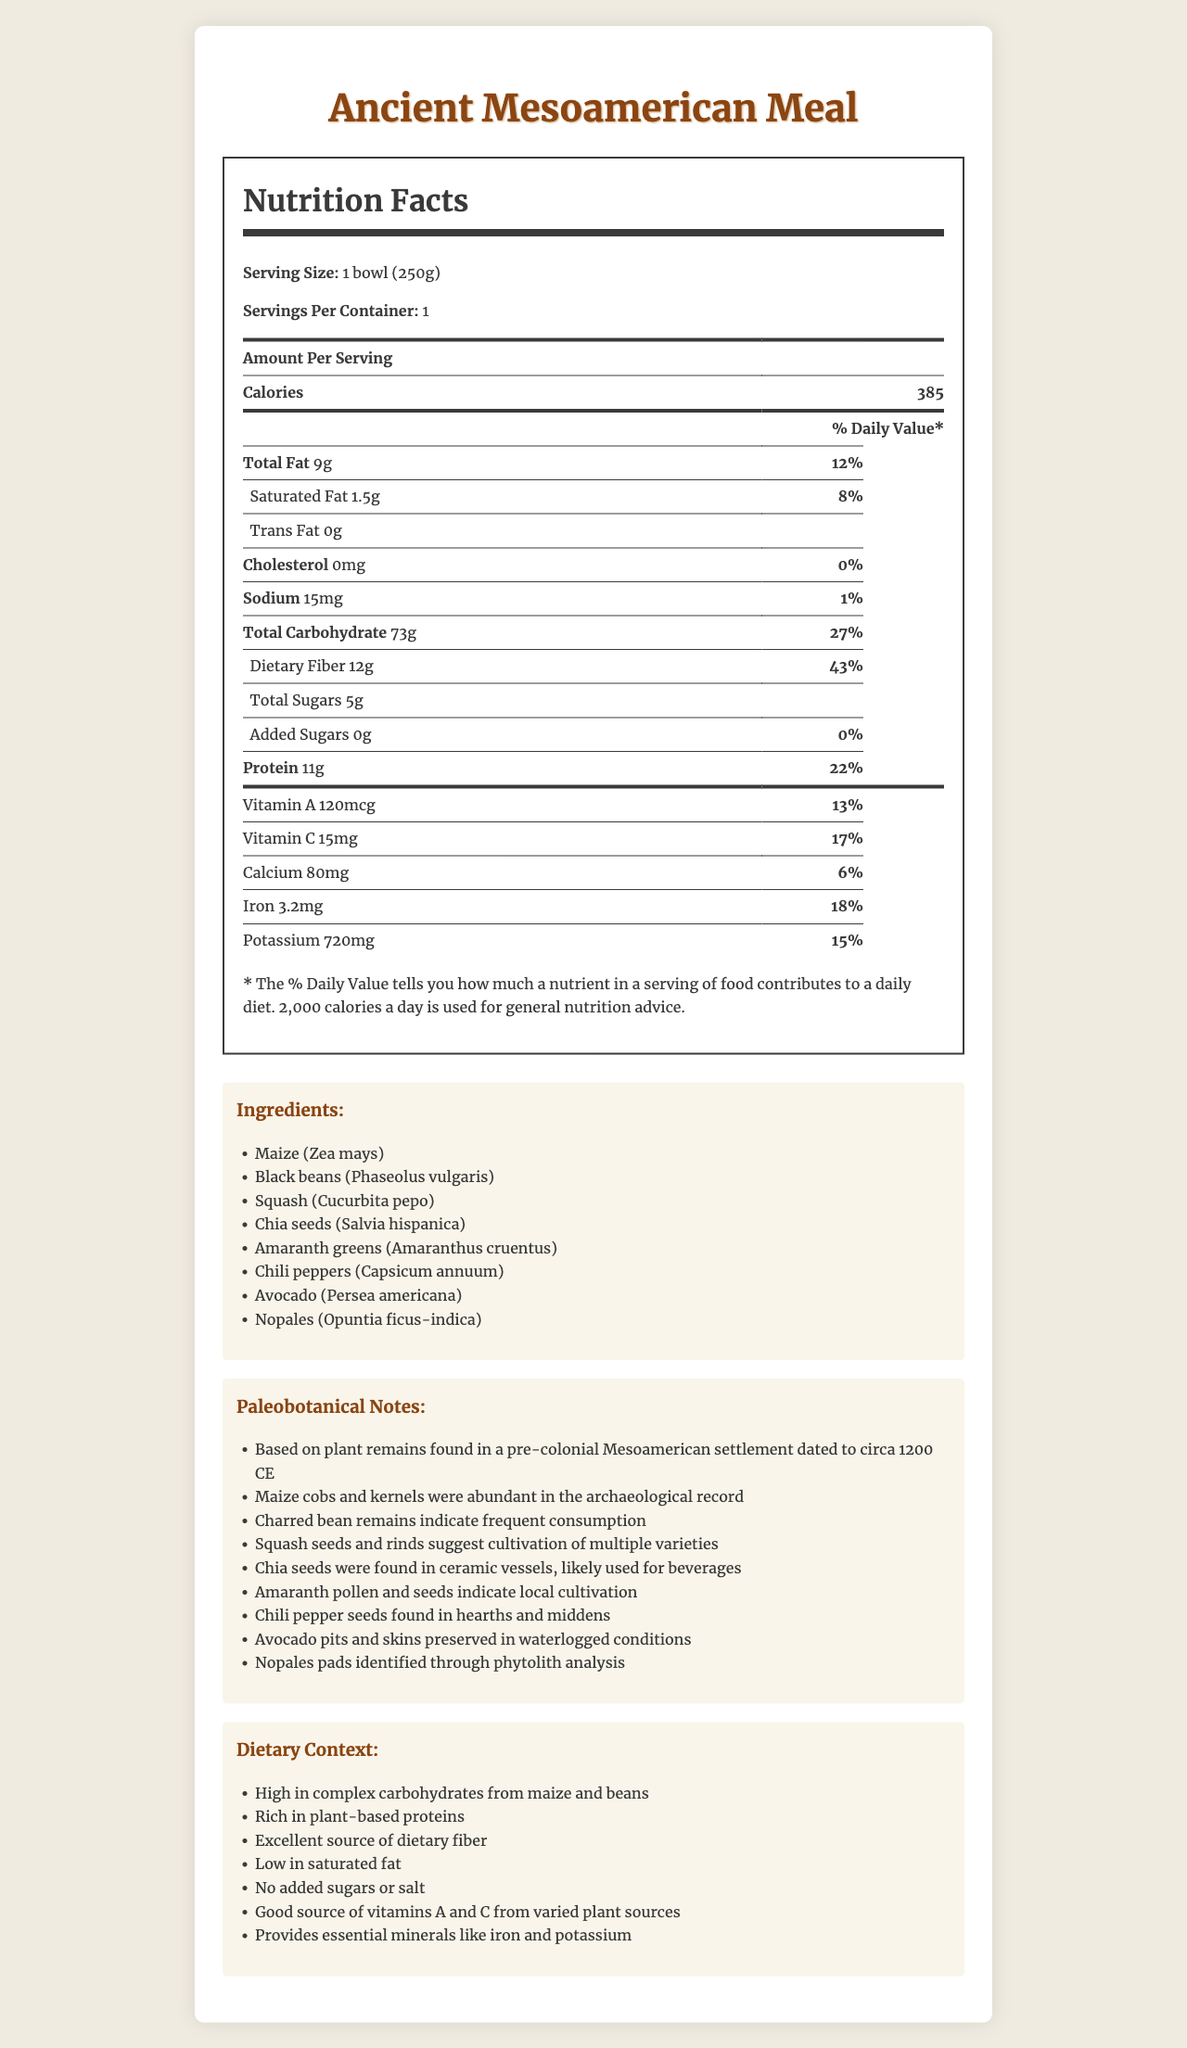what is the serving size of the Ancient Mesoamerican Meal? The serving size is specified at the top of the Nutrition Facts label as "1 bowl (250g)."
Answer: 1 bowl (250g) how many calories are in each serving? The document states that each serving contains 385 calories, highlighted under the "Amount Per Serving" section.
Answer: 385 which ingredient is primarily high in complex carbohydrates? According to the dietary context, maize is highlighted as being high in complex carbohydrates, which is typical for this grain.
Answer: Maize (Zea mays) list three sources of protein found in the Ancient Mesoamerican Meal. According to the ingredients list, black beans, chia seeds, and amaranth greens are all known sources of plant-based protein.
Answer: Black beans, chia seeds, amaranth greens what is the % Daily Value of Dietary Fiber? The % Daily Value for dietary fiber is 43%, as specified next to the dietary fiber content on the Nutrition Facts label.
Answer: 43% which of the following vitamins are provided by the Ancient Mesoamerican Meal?
A. Vitamin A
B. Vitamin C
C. Vitamin D The Nutrition Facts label shows that the meal provides Vitamin A (120mcg) and Vitamin C (15mg), but does not list Vitamin D.
Answer: A and B what is the total carbohydrate content per serving? The Nutrition Facts label lists 73 grams of total carbohydrates per serving, under the "Total Carbohydrate" section.
Answer: 73g does this meal contain any cholesterol? The Nutrition Facts label indicates 0mg of cholesterol, which means there is no cholesterol in the meal.
Answer: No which food item was found charred and suggests frequent consumption? The paleobotanical notes mention charred bean remains indicating frequent consumption, specifically referring to black beans.
Answer: Black beans what are the benefits highlighted in the dietary context of this meal? The dietary context section lists these benefits, providing a broad overview of the nutritional advantages of the meal.
Answer: High in complex carbohydrates, rich in plant-based proteins, excellent source of dietary fiber, low in saturated fat, no added sugars or salt, good source of vitamins A and C, essential minerals like iron and potassium could the amount of trans fat in this meal be determined from the document? The document shows that there is 0 grams of trans fat, indicating no trans fat content in the meal.
Answer: Yes what is the main idea of the document? The document offers a comprehensive overview of the meal's nutritional profile and background, emphasizing its basis on paleobotanical evidence and health benefits.
Answer: The document provides detailed nutritional information about an Ancient Mesoamerican Meal, including its ingredients, paleobotanical notes, dietary context, and allergen information, while highlighting the meal's nutritional benefits based on archaeological findings from a pre-colonial Mesoamerican settlement. what is the total amount of added sugars in the meal? The Nutrition Facts label states that there are 0 grams of added sugars in the meal.
Answer: 0g how much iron is present in the meal, expressed as a daily value percentage? The Nutrition Facts label shows that the meal contains 3.2 mg of iron, which corresponds to 18% of the daily value.
Answer: 18% are there any allergens listed for the Ancient Mesoamerican Meal? The document states explicitly that there are no allergens for this meal.
Answer: None 